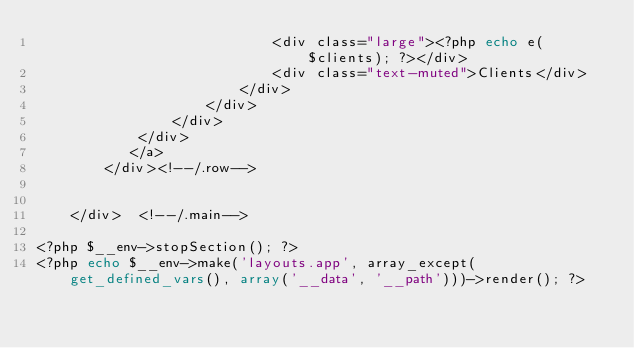<code> <loc_0><loc_0><loc_500><loc_500><_PHP_>                            <div class="large"><?php echo e($clients); ?></div>
                            <div class="text-muted">Clients</div>
                        </div>
                    </div>
                </div>
            </div>
           </a>
        </div><!--/.row-->       
                                      
       
    </div>  <!--/.main-->

<?php $__env->stopSection(); ?>
<?php echo $__env->make('layouts.app', array_except(get_defined_vars(), array('__data', '__path')))->render(); ?></code> 